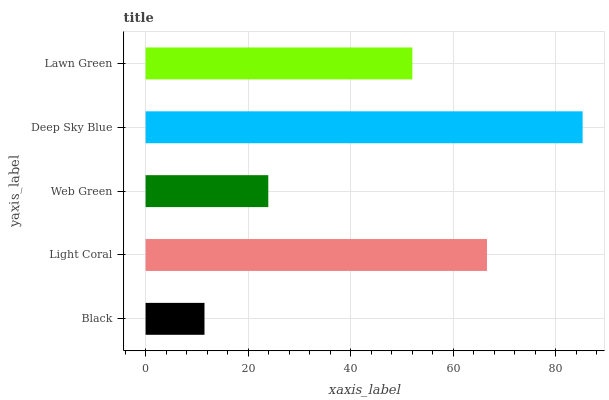Is Black the minimum?
Answer yes or no. Yes. Is Deep Sky Blue the maximum?
Answer yes or no. Yes. Is Light Coral the minimum?
Answer yes or no. No. Is Light Coral the maximum?
Answer yes or no. No. Is Light Coral greater than Black?
Answer yes or no. Yes. Is Black less than Light Coral?
Answer yes or no. Yes. Is Black greater than Light Coral?
Answer yes or no. No. Is Light Coral less than Black?
Answer yes or no. No. Is Lawn Green the high median?
Answer yes or no. Yes. Is Lawn Green the low median?
Answer yes or no. Yes. Is Web Green the high median?
Answer yes or no. No. Is Web Green the low median?
Answer yes or no. No. 